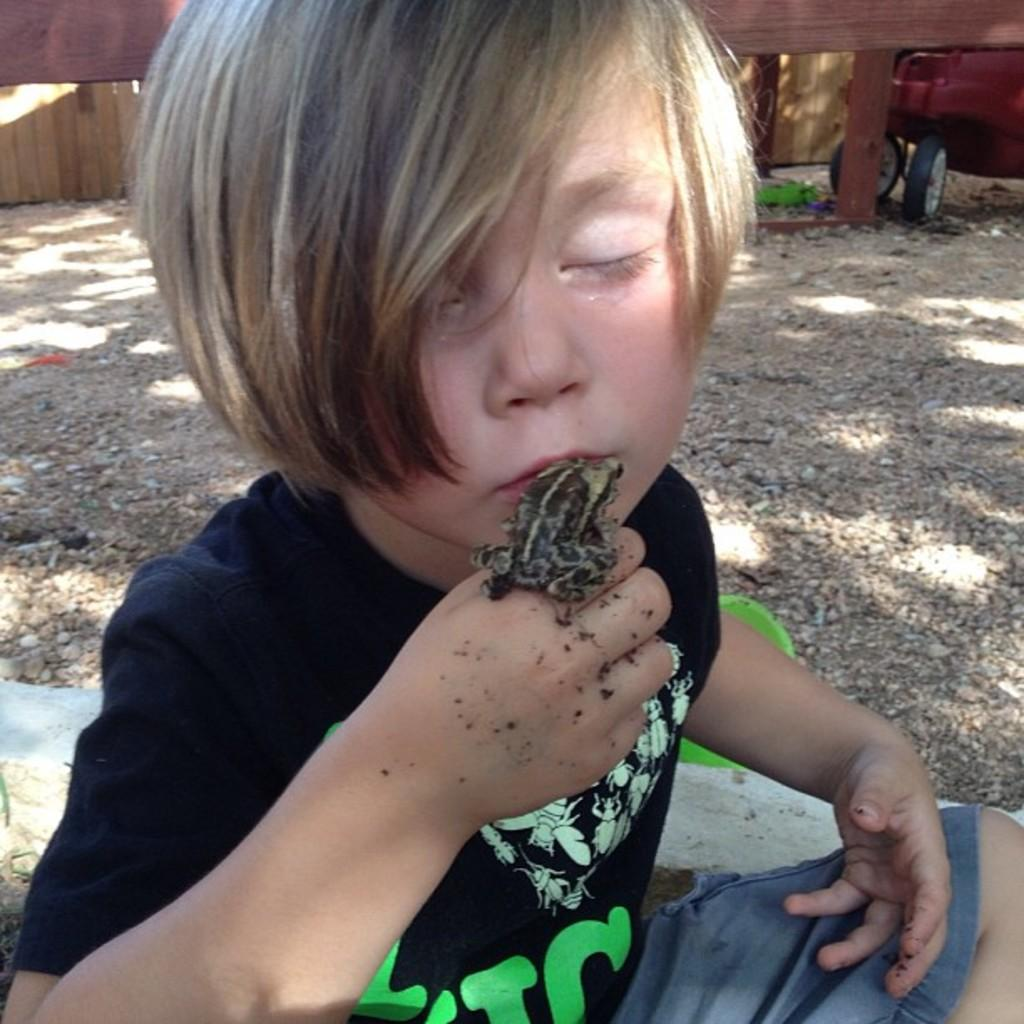Who is the main subject in the image? There is a boy in the image. What is the boy doing in the image? The boy is sitting on the ground. What is the boy holding in his hand? The boy is holding a frog in his hand. What can be seen in the background of the image? There is a vehicle and a wall in the background of the image. What type of oil can be seen dripping from the boy's hair in the image? There is no oil visible in the image, nor is the boy's hair mentioned. 